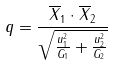Convert formula to latex. <formula><loc_0><loc_0><loc_500><loc_500>q = \frac { \overline { X } _ { 1 } \cdot \overline { X } _ { 2 } } { \sqrt { \frac { u _ { 1 } ^ { 2 } } { G _ { 1 } } + \frac { u _ { 2 } ^ { 2 } } { G _ { 2 } } } }</formula> 